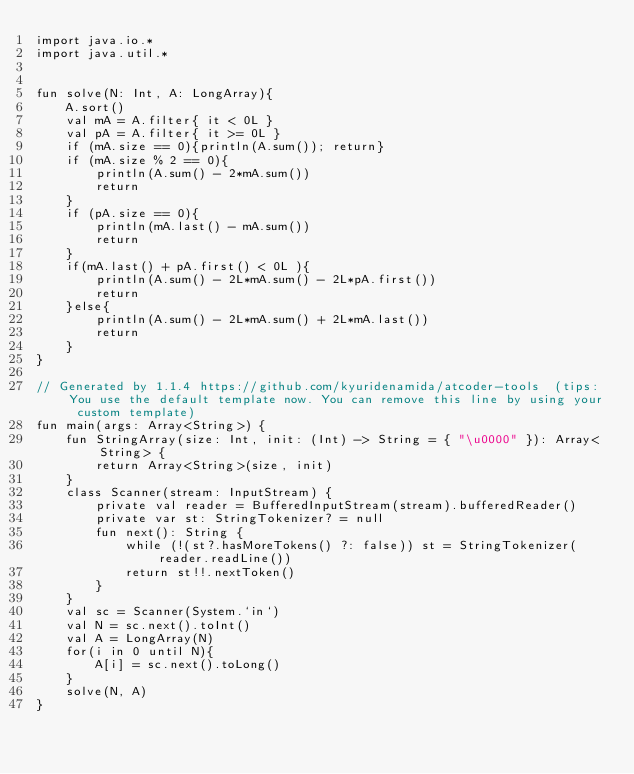<code> <loc_0><loc_0><loc_500><loc_500><_Kotlin_>import java.io.*
import java.util.*


fun solve(N: Int, A: LongArray){
    A.sort()
    val mA = A.filter{ it < 0L }
    val pA = A.filter{ it >= 0L }
    if (mA.size == 0){println(A.sum()); return}
    if (mA.size % 2 == 0){
        println(A.sum() - 2*mA.sum())
        return
    }
    if (pA.size == 0){
        println(mA.last() - mA.sum())
        return
    }
    if(mA.last() + pA.first() < 0L ){
        println(A.sum() - 2L*mA.sum() - 2L*pA.first())
        return
    }else{
        println(A.sum() - 2L*mA.sum() + 2L*mA.last())
        return
    }
}

// Generated by 1.1.4 https://github.com/kyuridenamida/atcoder-tools  (tips: You use the default template now. You can remove this line by using your custom template)
fun main(args: Array<String>) {
    fun StringArray(size: Int, init: (Int) -> String = { "\u0000" }): Array<String> {
        return Array<String>(size, init)
    }
    class Scanner(stream: InputStream) {
        private val reader = BufferedInputStream(stream).bufferedReader()
        private var st: StringTokenizer? = null
        fun next(): String {
            while (!(st?.hasMoreTokens() ?: false)) st = StringTokenizer(reader.readLine())
            return st!!.nextToken()
        }
    }
    val sc = Scanner(System.`in`)
    val N = sc.next().toInt()
    val A = LongArray(N)
    for(i in 0 until N){
        A[i] = sc.next().toLong()
    }
    solve(N, A)
}


</code> 